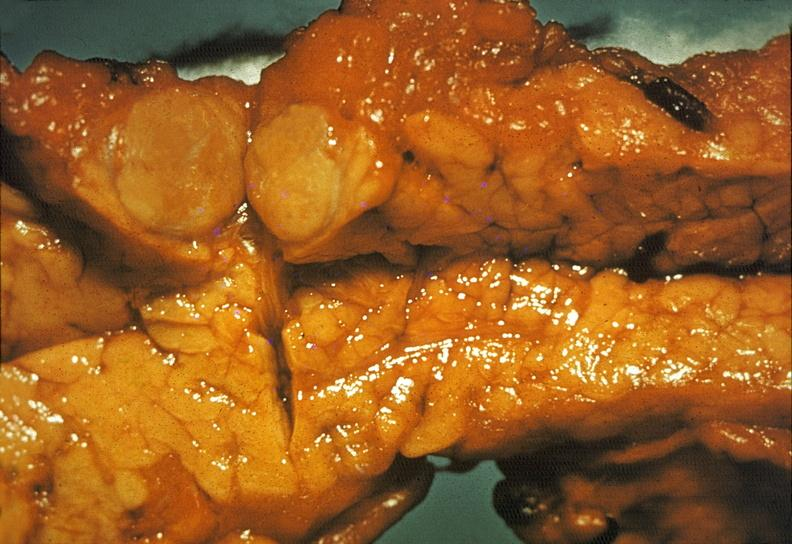does this image show islet cell carcinoma?
Answer the question using a single word or phrase. Yes 